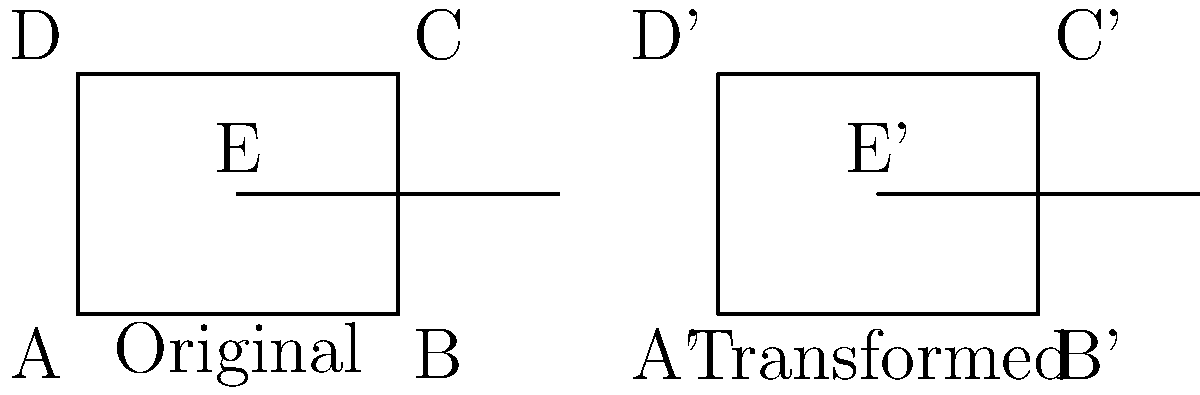The figure represents the transformation of Bishop McGann-Mercy High School's layout during different stages of its history. The original rectangle ABCD represents the school's initial structure, with point E marking a significant location (e.g., the main entrance). After a renovation project, the school's layout was transformed to A'B'C'D' with E' as the new significant point. If this transformation is a rigid motion, what type of transformation was applied, and what is the magnitude of the transformation? To determine the type of transformation and its magnitude, we need to analyze the properties of the original and transformed figures:

1. Shape preservation: The transformed figure A'B'C'D' maintains the same shape and size as ABCD, indicating a rigid motion.

2. Orientation preservation: The orientation of the figure remains the same, ruling out a reflection.

3. Relative positions: All points have moved the same distance in the same direction, suggesting a translation.

To calculate the magnitude of the translation:

4. Choose any pair of corresponding points, e.g., A and A':
   - A = (0,0)
   - A' = (8,0)

5. Calculate the displacement vector:
   $\vec{v} = A' - A = (8-0, 0-0) = (8,0)$

6. The magnitude of the translation is the length of this vector:
   $|\vec{v}| = \sqrt{8^2 + 0^2} = 8$ units

Therefore, the transformation is a translation 8 units to the right.
Answer: Translation, 8 units right 